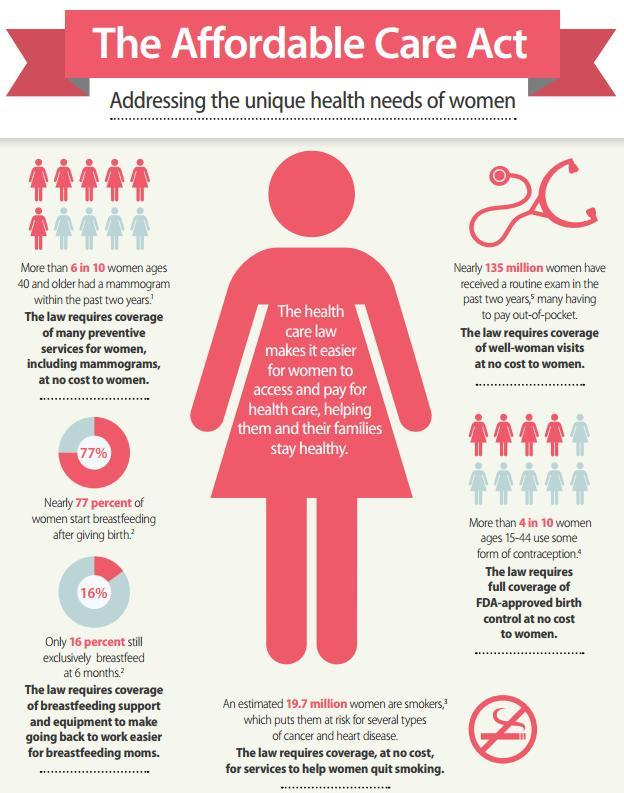What percentage of women do not necessarily breast feed after 6 months ?
Answer the question with a short phrase. 84% 